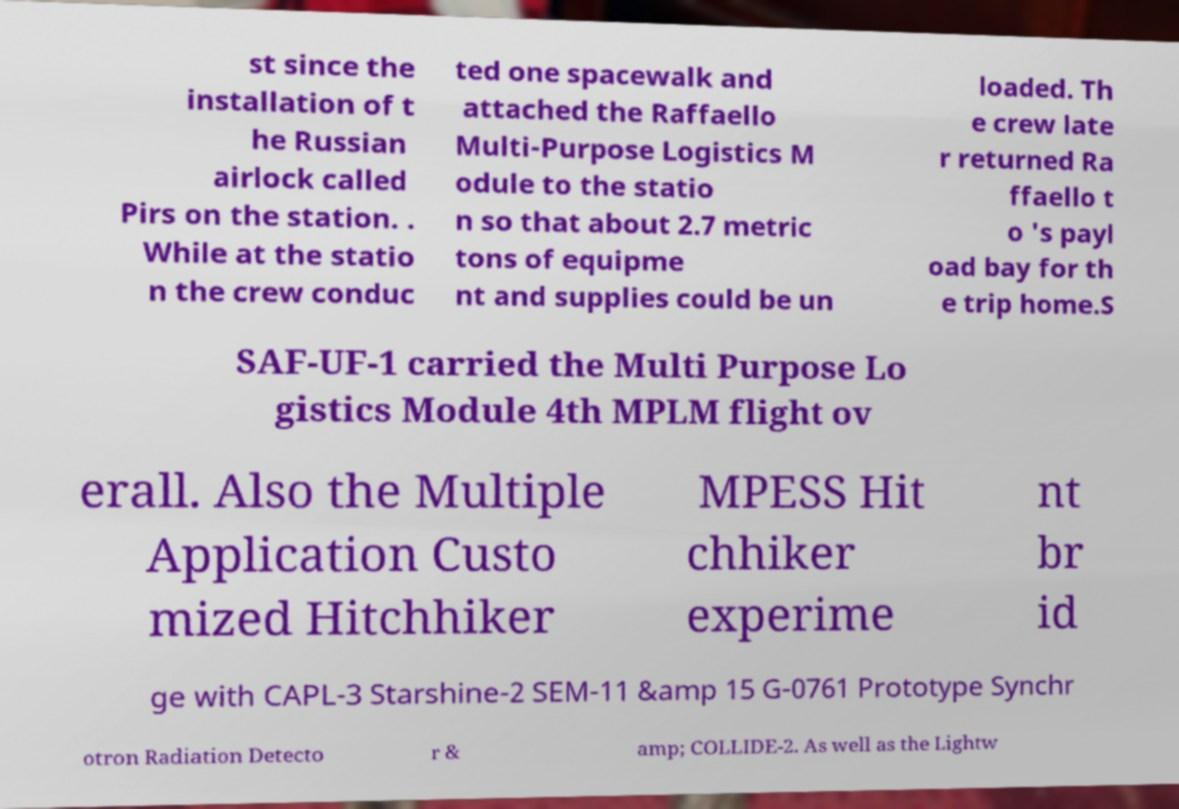I need the written content from this picture converted into text. Can you do that? st since the installation of t he Russian airlock called Pirs on the station. . While at the statio n the crew conduc ted one spacewalk and attached the Raffaello Multi-Purpose Logistics M odule to the statio n so that about 2.7 metric tons of equipme nt and supplies could be un loaded. Th e crew late r returned Ra ffaello t o 's payl oad bay for th e trip home.S SAF-UF-1 carried the Multi Purpose Lo gistics Module 4th MPLM flight ov erall. Also the Multiple Application Custo mized Hitchhiker MPESS Hit chhiker experime nt br id ge with CAPL-3 Starshine-2 SEM-11 &amp 15 G-0761 Prototype Synchr otron Radiation Detecto r & amp; COLLIDE-2. As well as the Lightw 